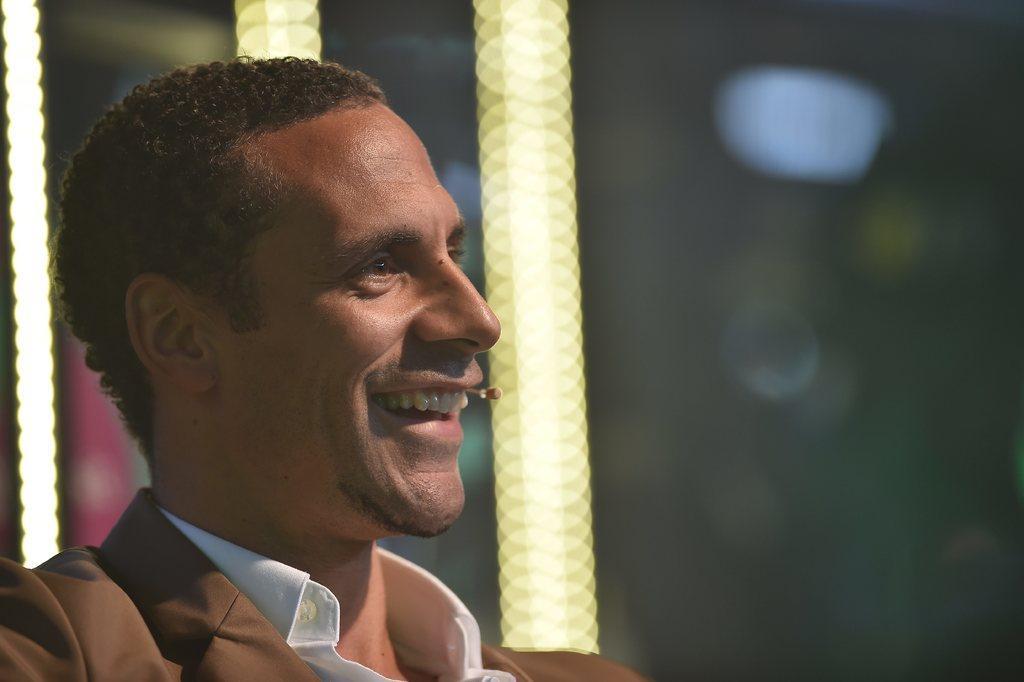Describe this image in one or two sentences. In the foreground of the image there is a person smiling. The background of the image is blurred. 